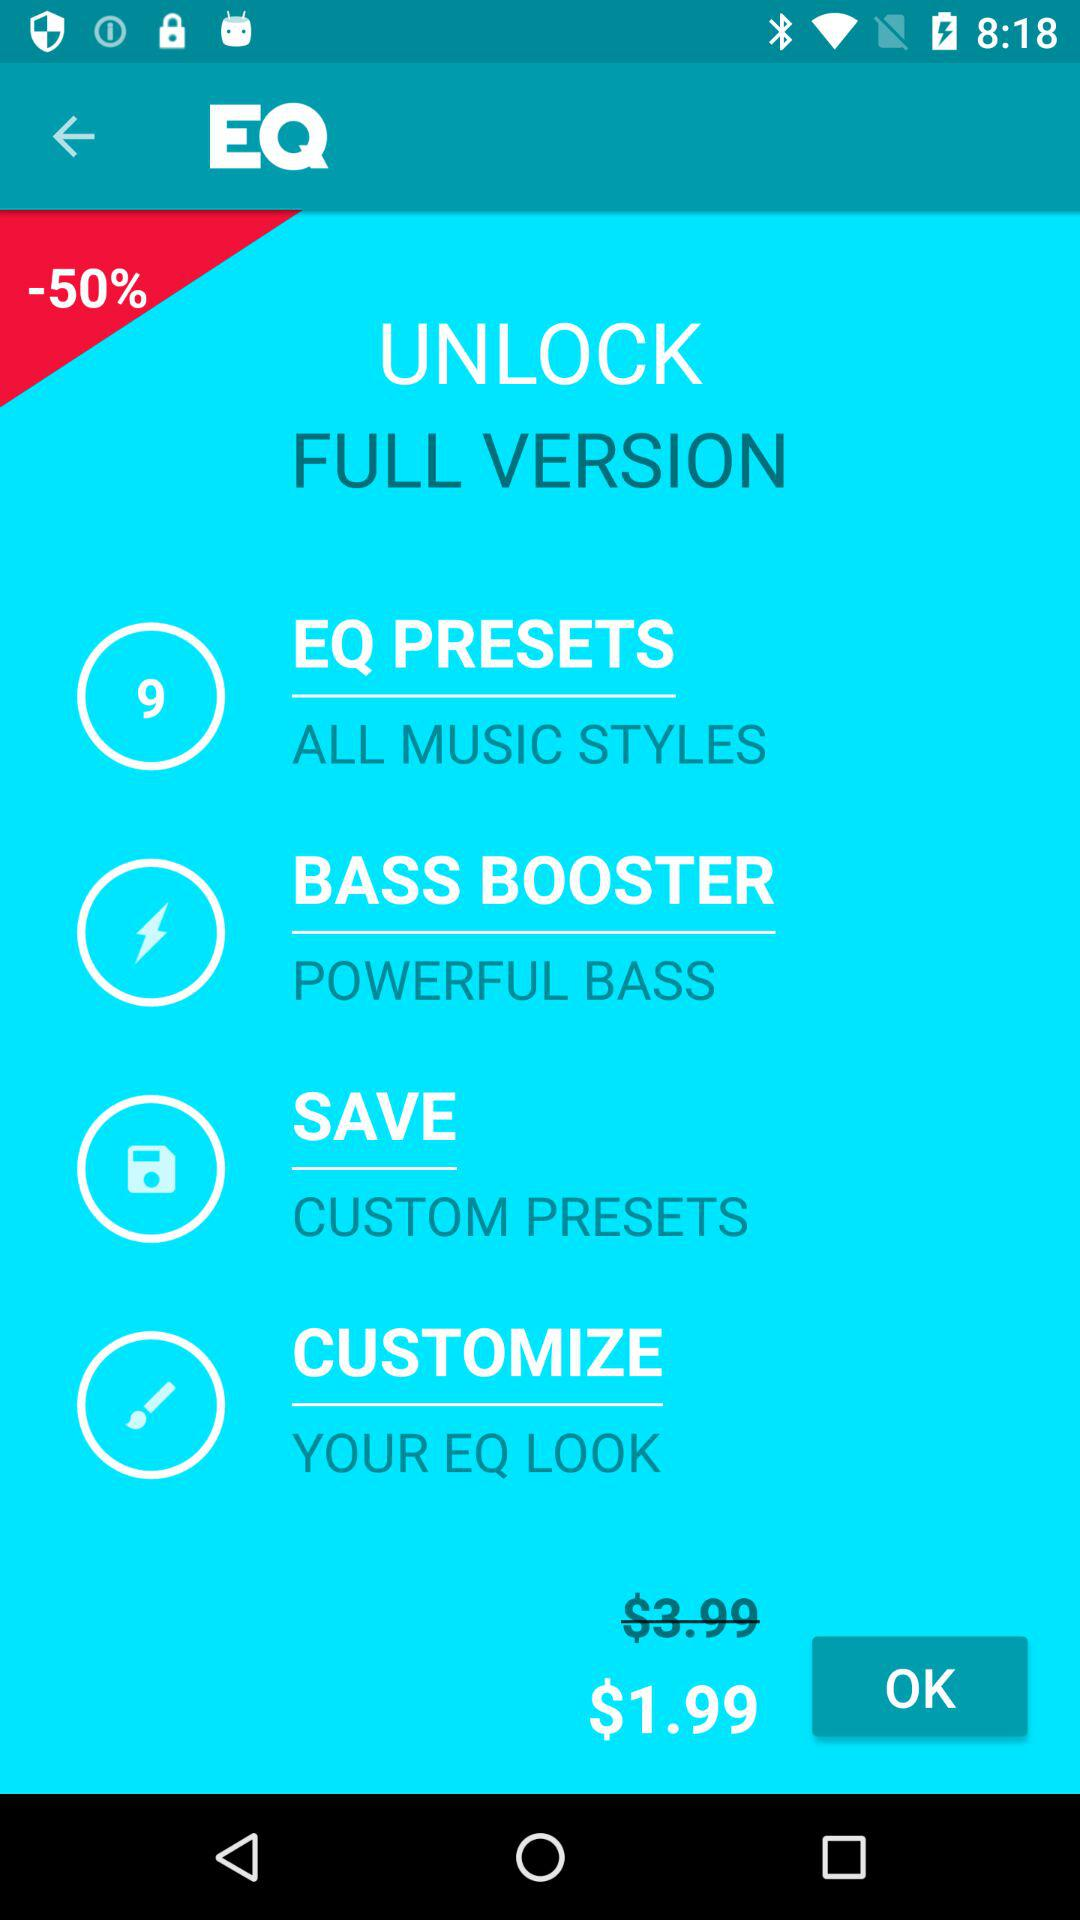How much money is saved by buying the full version?
Answer the question using a single word or phrase. $2.00 